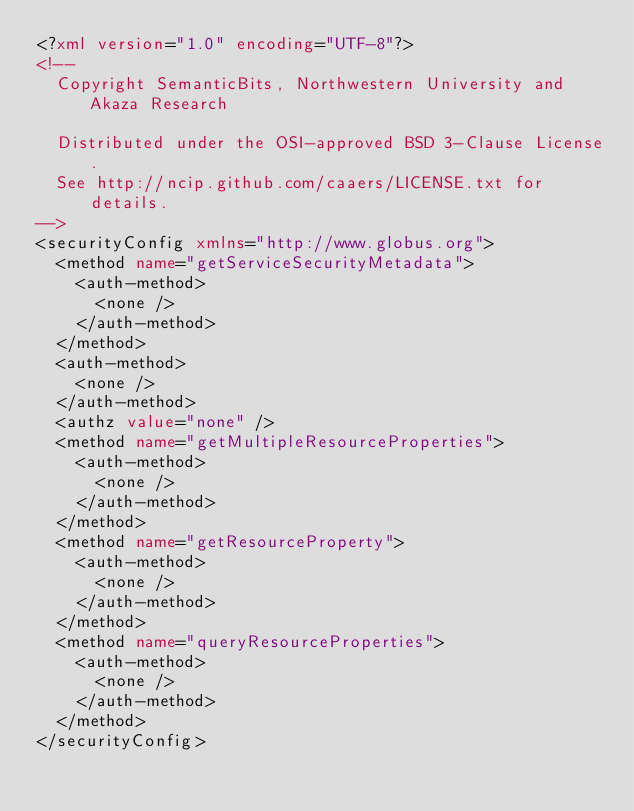<code> <loc_0><loc_0><loc_500><loc_500><_XML_><?xml version="1.0" encoding="UTF-8"?>
<!--
  Copyright SemanticBits, Northwestern University and Akaza Research
  
  Distributed under the OSI-approved BSD 3-Clause License.
  See http://ncip.github.com/caaers/LICENSE.txt for details.
-->
<securityConfig xmlns="http://www.globus.org">
  <method name="getServiceSecurityMetadata">
    <auth-method>
      <none />
    </auth-method>
  </method>
  <auth-method>
    <none />
  </auth-method>
  <authz value="none" />
  <method name="getMultipleResourceProperties">
    <auth-method>
      <none />
    </auth-method>
  </method>
  <method name="getResourceProperty">
    <auth-method>
      <none />
    </auth-method>
  </method>
  <method name="queryResourceProperties">
    <auth-method>
      <none />
    </auth-method>
  </method>
</securityConfig>


</code> 